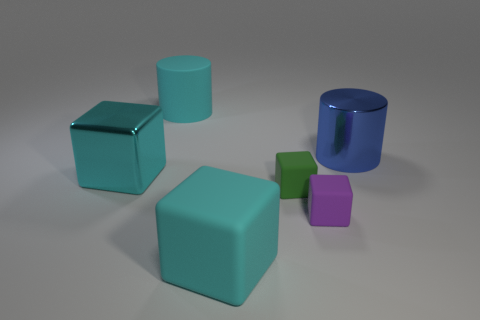What shape is the large object that is behind the large metal block and left of the big metallic cylinder?
Ensure brevity in your answer.  Cylinder. Is the color of the large matte cylinder the same as the big object to the left of the big rubber cylinder?
Make the answer very short. Yes. The large matte object behind the big cyan thing right of the big cyan matte object that is behind the big cyan matte block is what color?
Offer a very short reply. Cyan. There is another big thing that is the same shape as the large blue shiny object; what color is it?
Offer a terse response. Cyan. Are there the same number of objects that are to the right of the big shiny cylinder and big blue cylinders?
Keep it short and to the point. No. How many blocks are small green rubber objects or tiny purple rubber objects?
Make the answer very short. 2. What color is the large block that is the same material as the green thing?
Keep it short and to the point. Cyan. Does the big blue cylinder have the same material as the small cube that is behind the small purple cube?
Your answer should be very brief. No. How many things are big cyan cylinders or large cylinders?
Your answer should be very brief. 2. What material is the other block that is the same color as the big shiny cube?
Give a very brief answer. Rubber. 